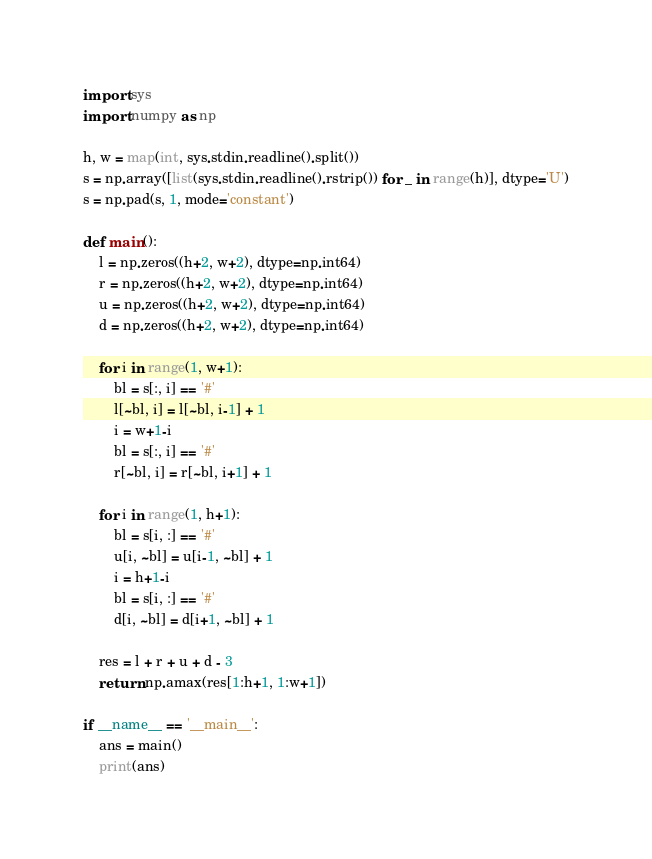<code> <loc_0><loc_0><loc_500><loc_500><_Python_>import sys
import numpy as np 

h, w = map(int, sys.stdin.readline().split())
s = np.array([list(sys.stdin.readline().rstrip()) for _ in range(h)], dtype='U')
s = np.pad(s, 1, mode='constant')

def main():
    l = np.zeros((h+2, w+2), dtype=np.int64)
    r = np.zeros((h+2, w+2), dtype=np.int64)
    u = np.zeros((h+2, w+2), dtype=np.int64)
    d = np.zeros((h+2, w+2), dtype=np.int64)

    for i in range(1, w+1):
        bl = s[:, i] == '#'
        l[~bl, i] = l[~bl, i-1] + 1
        i = w+1-i
        bl = s[:, i] == '#'
        r[~bl, i] = r[~bl, i+1] + 1
    
    for i in range(1, h+1):
        bl = s[i, :] == '#'
        u[i, ~bl] = u[i-1, ~bl] + 1
        i = h+1-i
        bl = s[i, :] == '#'
        d[i, ~bl] = d[i+1, ~bl] + 1
    
    res = l + r + u + d - 3
    return np.amax(res[1:h+1, 1:w+1])

if __name__ == '__main__':
    ans = main()
    print(ans)</code> 